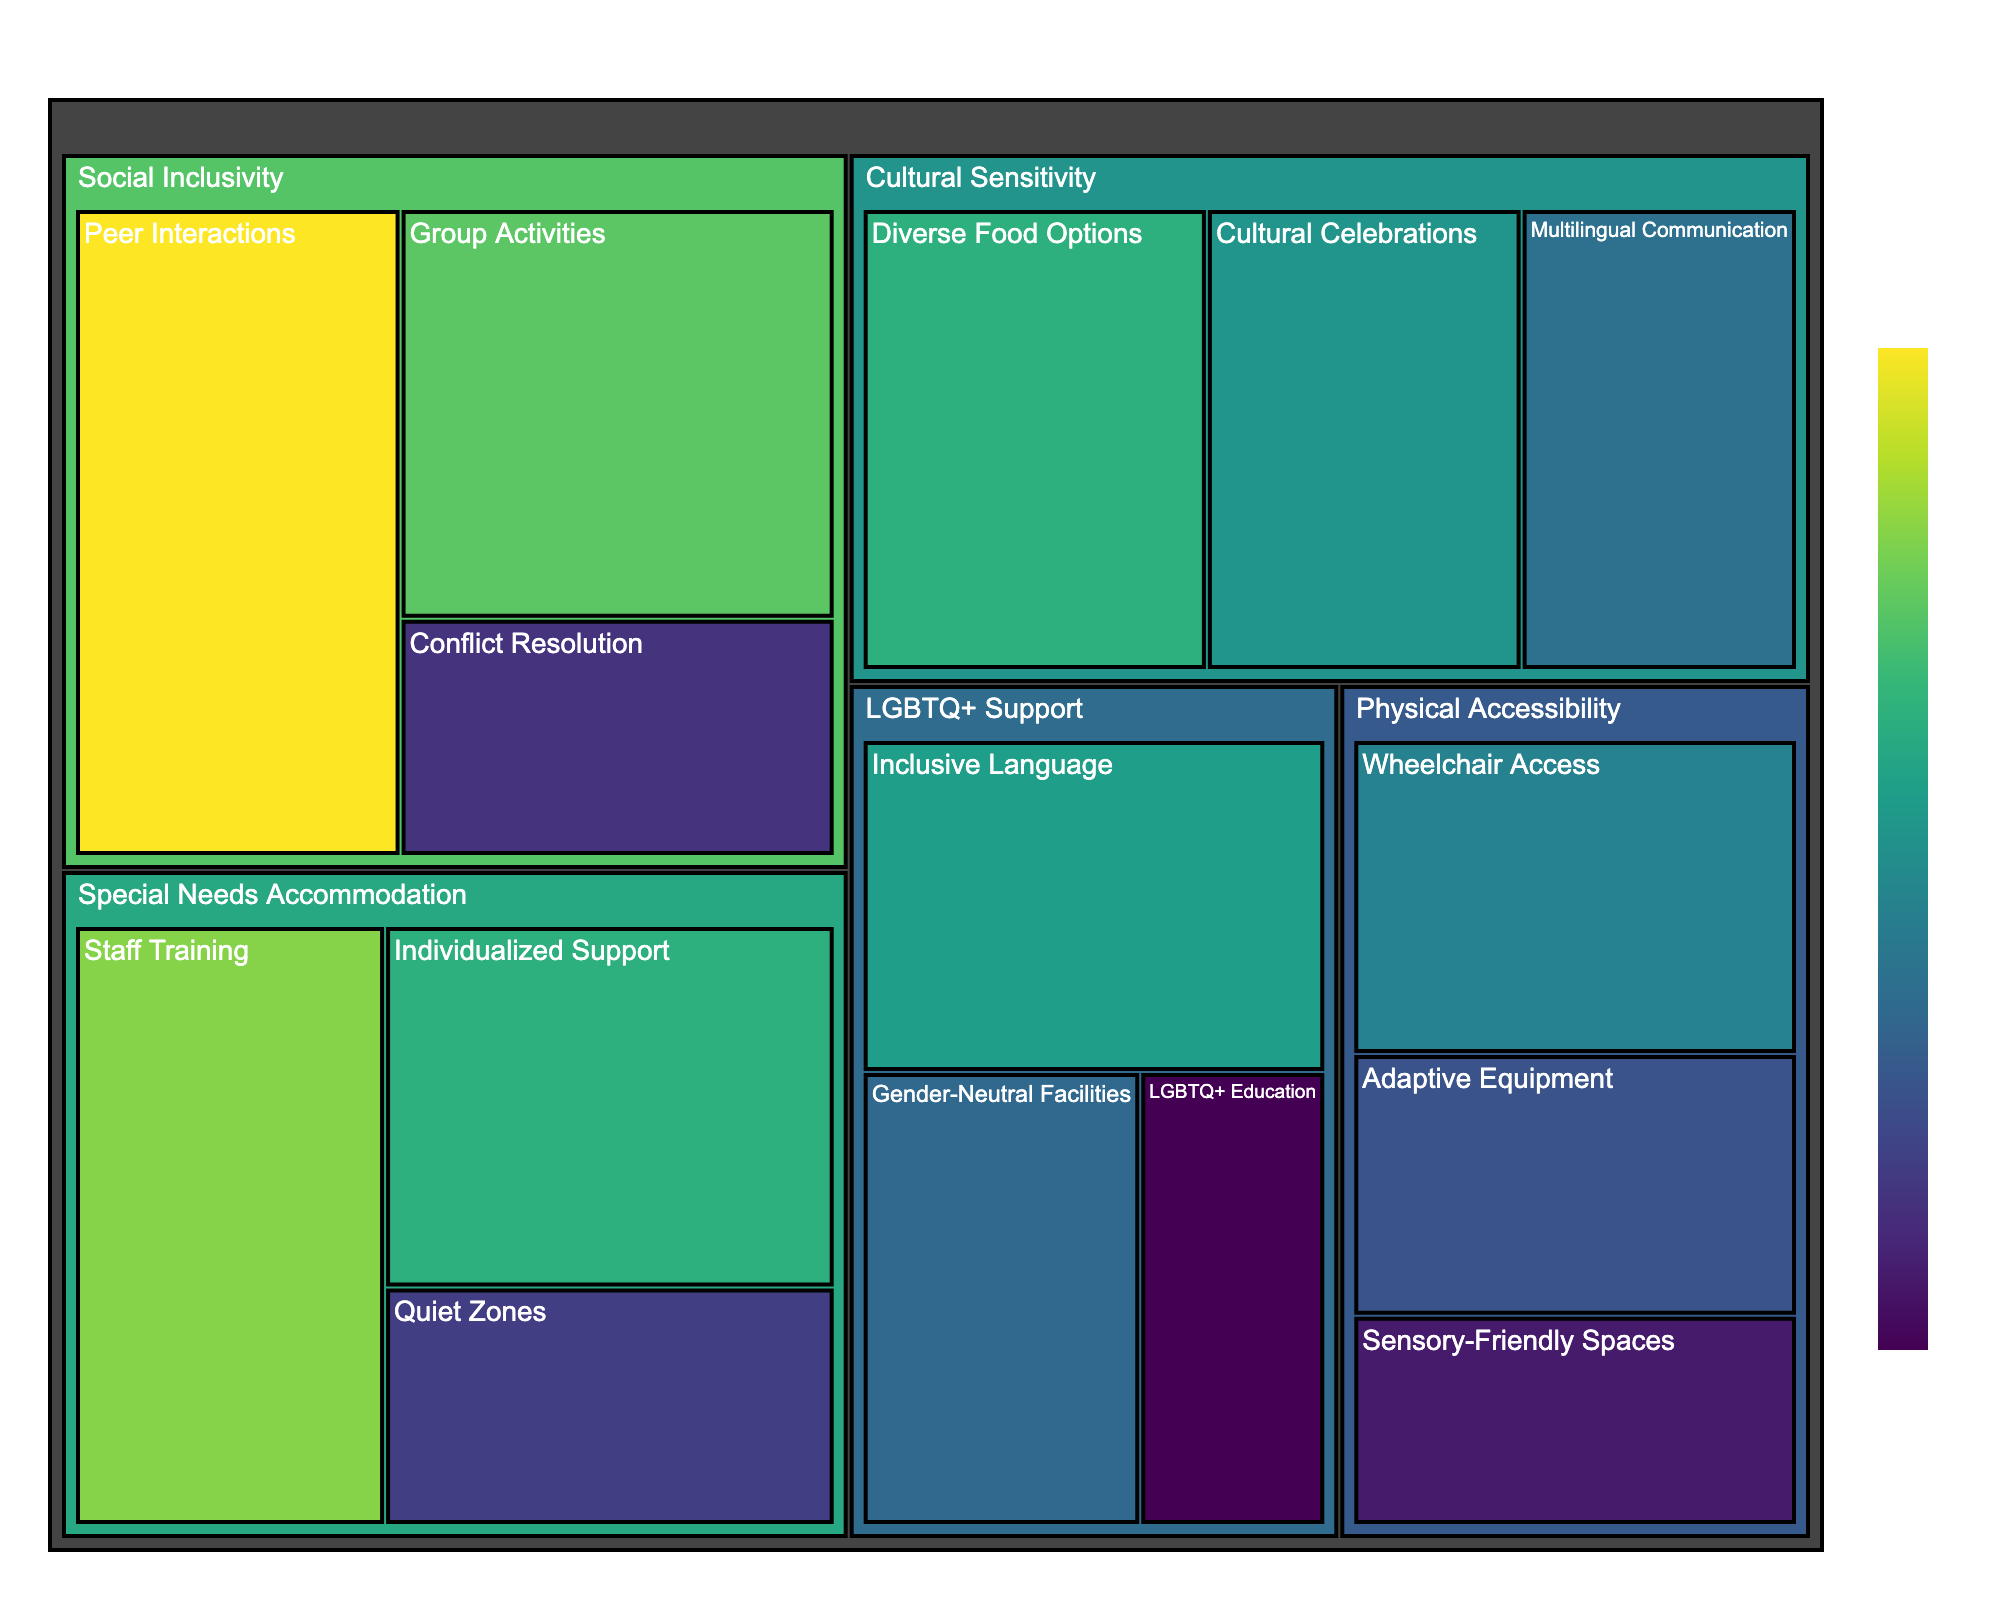what is the category with the highest value in total? Sum the values of each subcategory in each category, then compare the totals. Social Inclusivity: 45+38+22=105, Physical Accessibility: 30+25+20=75, Cultural Sensitivity: 35+28+32=95, LGBTQ+ Support: 27+33+18=78, Special Needs Accommodation: 40+35+23=98. Social Inclusivity has the highest total.
Answer: Social Inclusivity Which subcategory has the lowest value? Compare the values of each subcategory directly. The lowest value is for LGBTQ+ Education at 18.
Answer: LGBTQ+ Education What is the combined value for all categories related to physical accessibility? Sum the values of the subcategories under Physical Accessibility: Wheelchair Access (30), Adaptive Equipment (25), and Sensory-Friendly Spaces (20). 30+25+20 makes 75.
Answer: 75 Which subcategory in Social Inclusivity received the least feedback? Compare the values of the subcategories under Social Inclusivity. Conflict Resolution has the lowest feedback with a value of 22.
Answer: Conflict Resolution How many categories have at least one subcategory with a value greater than 30? Check each category for subcategories with values over 30. Social Inclusivity (45, 38), Physical Accessibility (none), Cultural Sensitivity (35, 32), LGBTQ+ Support (33), Special Needs Accommodation (40, 35). Four categories meet this criterion: Social Inclusivity, Cultural Sensitivity, LGBTQ+ Support, and Special Needs Accommodation.
Answer: Four 